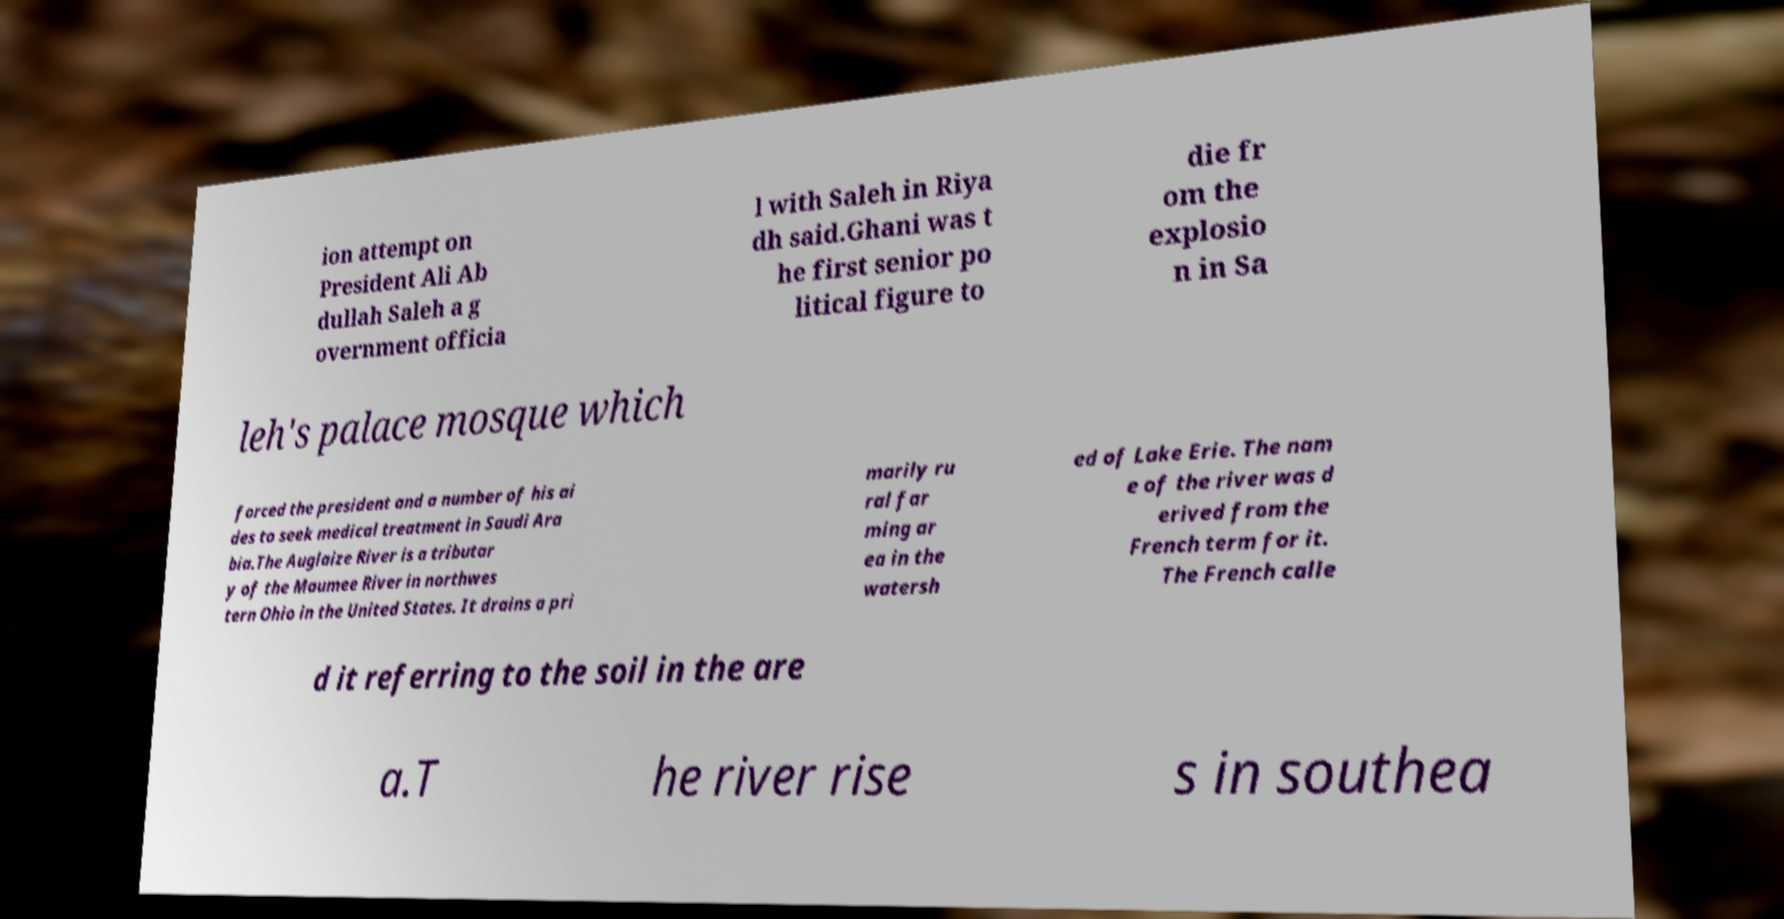Could you extract and type out the text from this image? ion attempt on President Ali Ab dullah Saleh a g overnment officia l with Saleh in Riya dh said.Ghani was t he first senior po litical figure to die fr om the explosio n in Sa leh's palace mosque which forced the president and a number of his ai des to seek medical treatment in Saudi Ara bia.The Auglaize River is a tributar y of the Maumee River in northwes tern Ohio in the United States. It drains a pri marily ru ral far ming ar ea in the watersh ed of Lake Erie. The nam e of the river was d erived from the French term for it. The French calle d it referring to the soil in the are a.T he river rise s in southea 